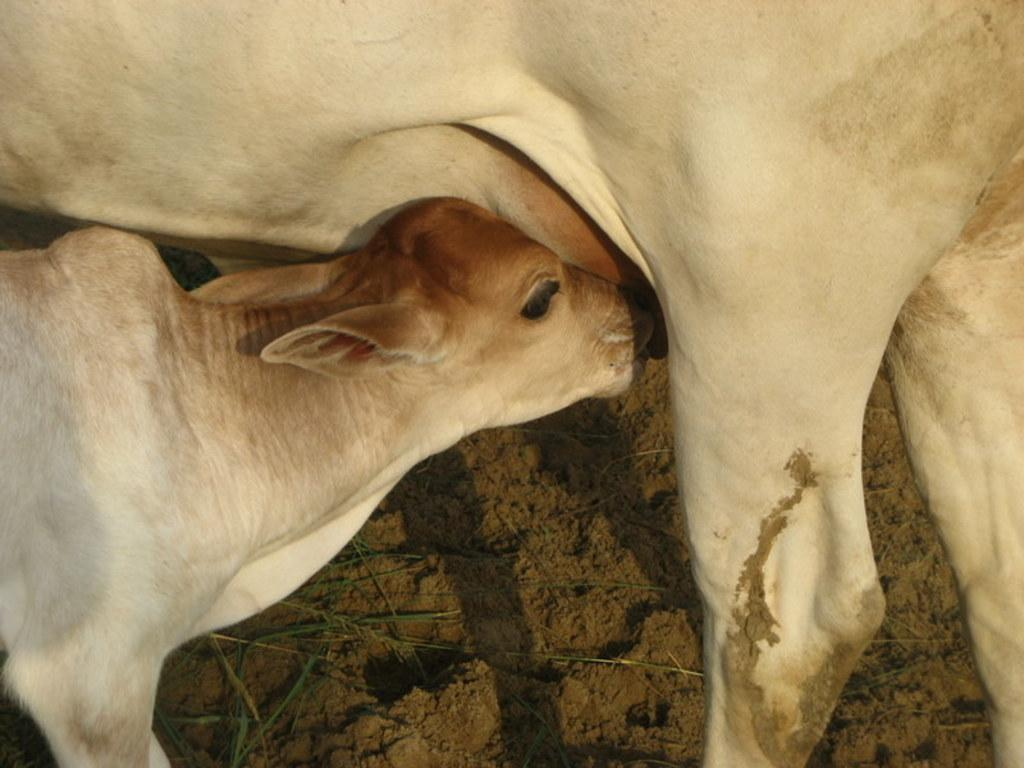What type of animal can be seen in the image? There is a cow in the image. Can you identify any other animals in the image? Yes, there is a calf in the image. What are the positions of the cow and calf in the image? The cow and calf are standing in the image. What type of terrain is depicted in the image? The image appears to depict mud, and there may be grass present as well. What is the price of the argument between the cow and calf in the image? There is no argument between the cow and calf in the image, and therefore no price can be determined. 